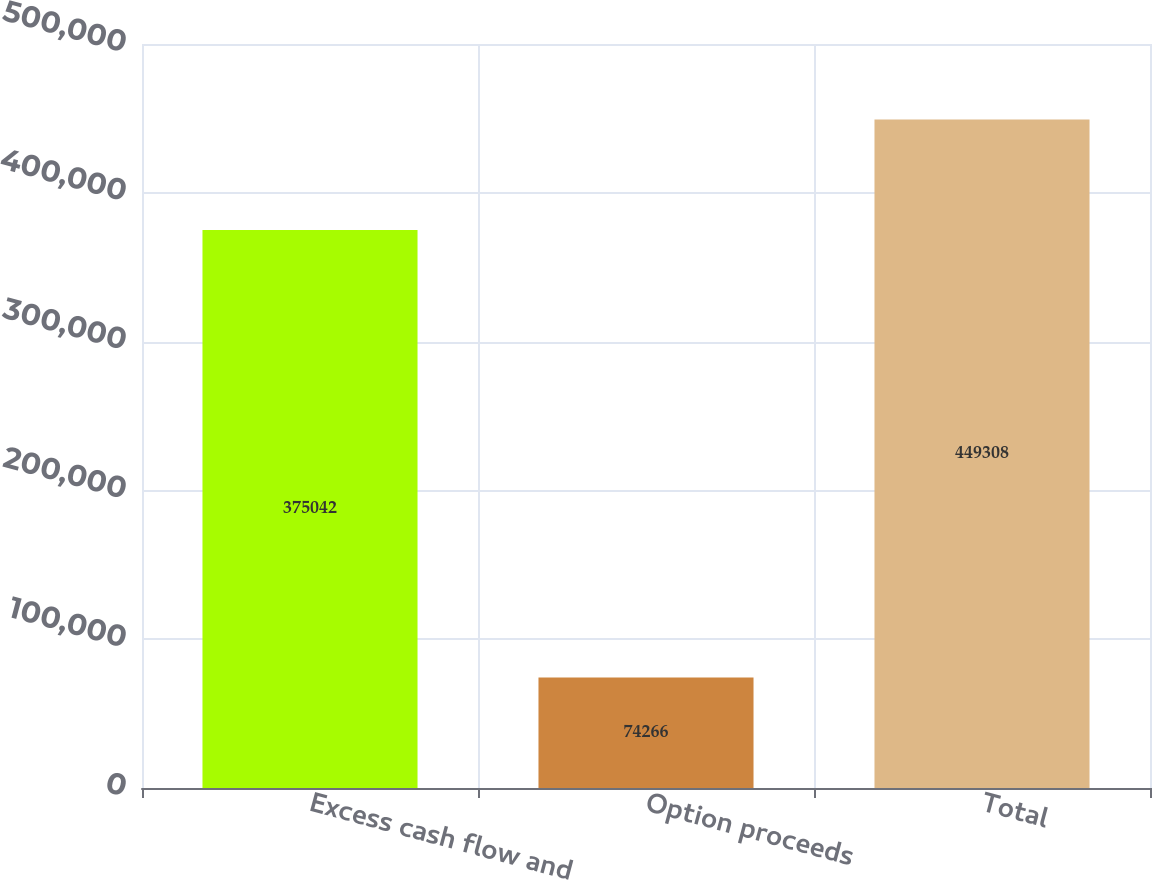Convert chart to OTSL. <chart><loc_0><loc_0><loc_500><loc_500><bar_chart><fcel>Excess cash flow and<fcel>Option proceeds<fcel>Total<nl><fcel>375042<fcel>74266<fcel>449308<nl></chart> 